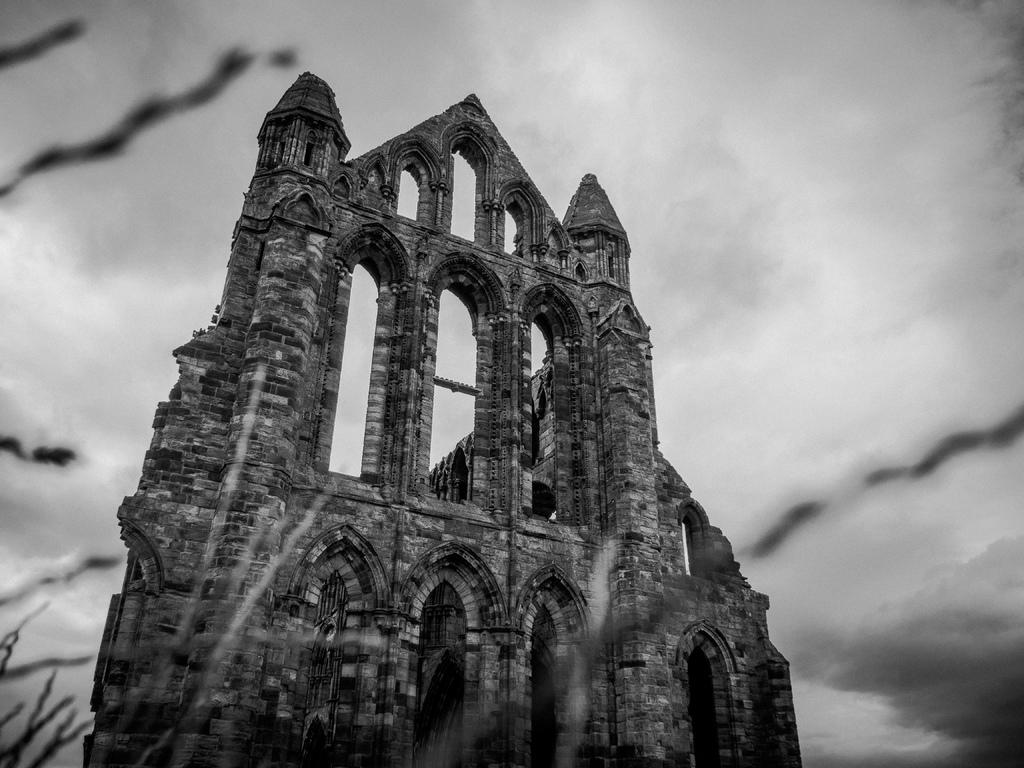What is the main subject in the middle of the image? There is a monument in the middle of the image. What can be seen in the background of the image? The sky is visible in the background of the image. Reasoning: Let's think step by step by step in order to produce the conversation. We start by identifying the main subject in the image, which is the monument. Then, we expand the conversation to include the background of the image, which is the sky. Each question is designed to elicit a specific detail about the image that is known from the provided facts. Absurd Question/Answer: What type of silk fabric is draped over the monument in the image? There is no silk fabric present in the image; the monument is the main subject. How much salt is visible on the monument in the image? There is no salt present on the monument in the image; the monument is the main subject. 